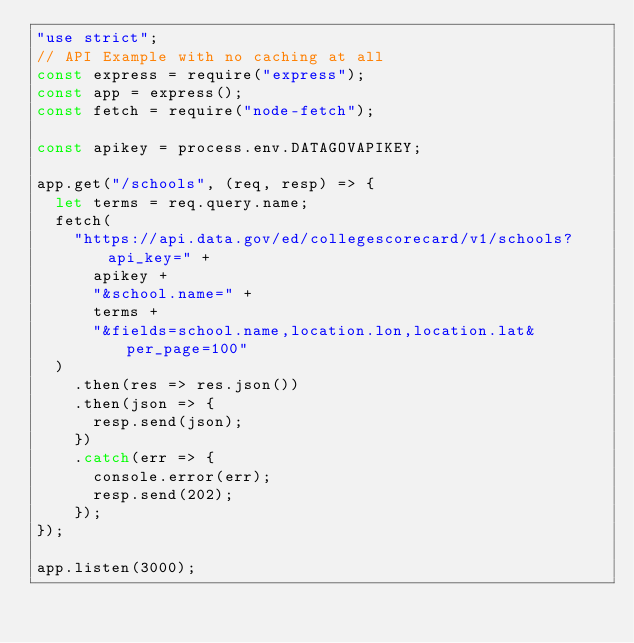<code> <loc_0><loc_0><loc_500><loc_500><_JavaScript_>"use strict";
// API Example with no caching at all
const express = require("express");
const app = express();
const fetch = require("node-fetch");

const apikey = process.env.DATAGOVAPIKEY;

app.get("/schools", (req, resp) => {
  let terms = req.query.name;
  fetch(
    "https://api.data.gov/ed/collegescorecard/v1/schools?api_key=" +
      apikey +
      "&school.name=" +
      terms +
      "&fields=school.name,location.lon,location.lat&per_page=100"
  )
    .then(res => res.json())
    .then(json => {
      resp.send(json);
    })
    .catch(err => {
      console.error(err);
      resp.send(202);
    });
});

app.listen(3000);
</code> 